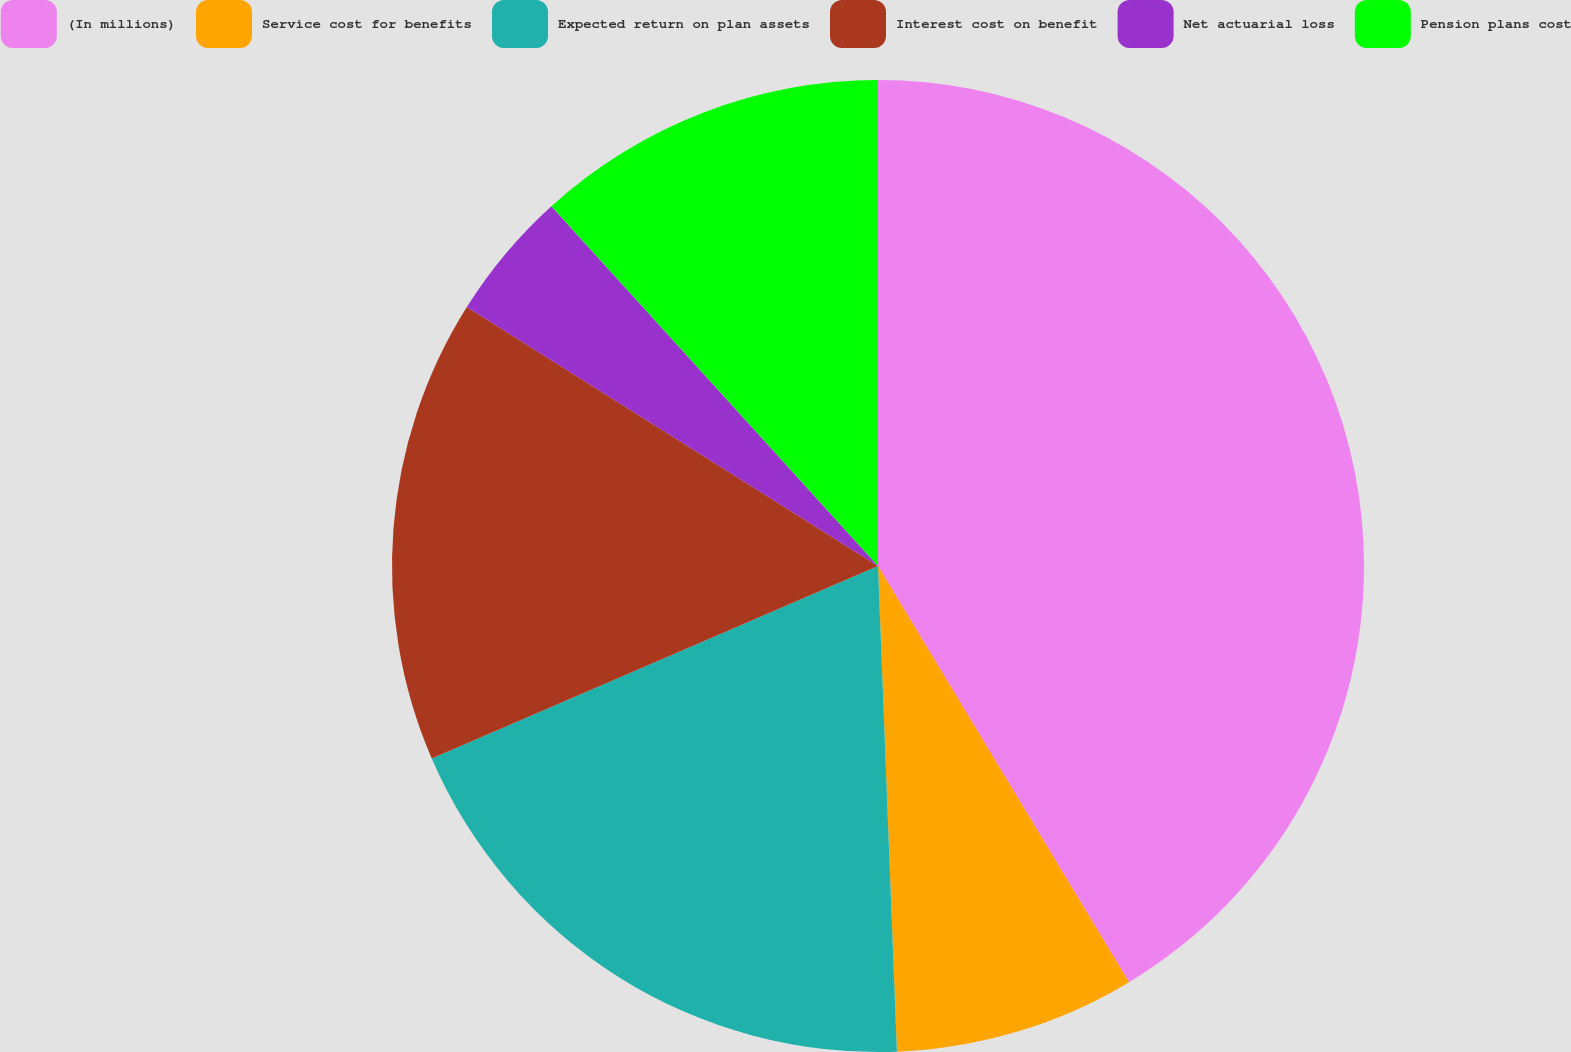Convert chart to OTSL. <chart><loc_0><loc_0><loc_500><loc_500><pie_chart><fcel>(In millions)<fcel>Service cost for benefits<fcel>Expected return on plan assets<fcel>Interest cost on benefit<fcel>Net actuarial loss<fcel>Pension plans cost<nl><fcel>41.36%<fcel>8.02%<fcel>19.14%<fcel>15.43%<fcel>4.32%<fcel>11.73%<nl></chart> 